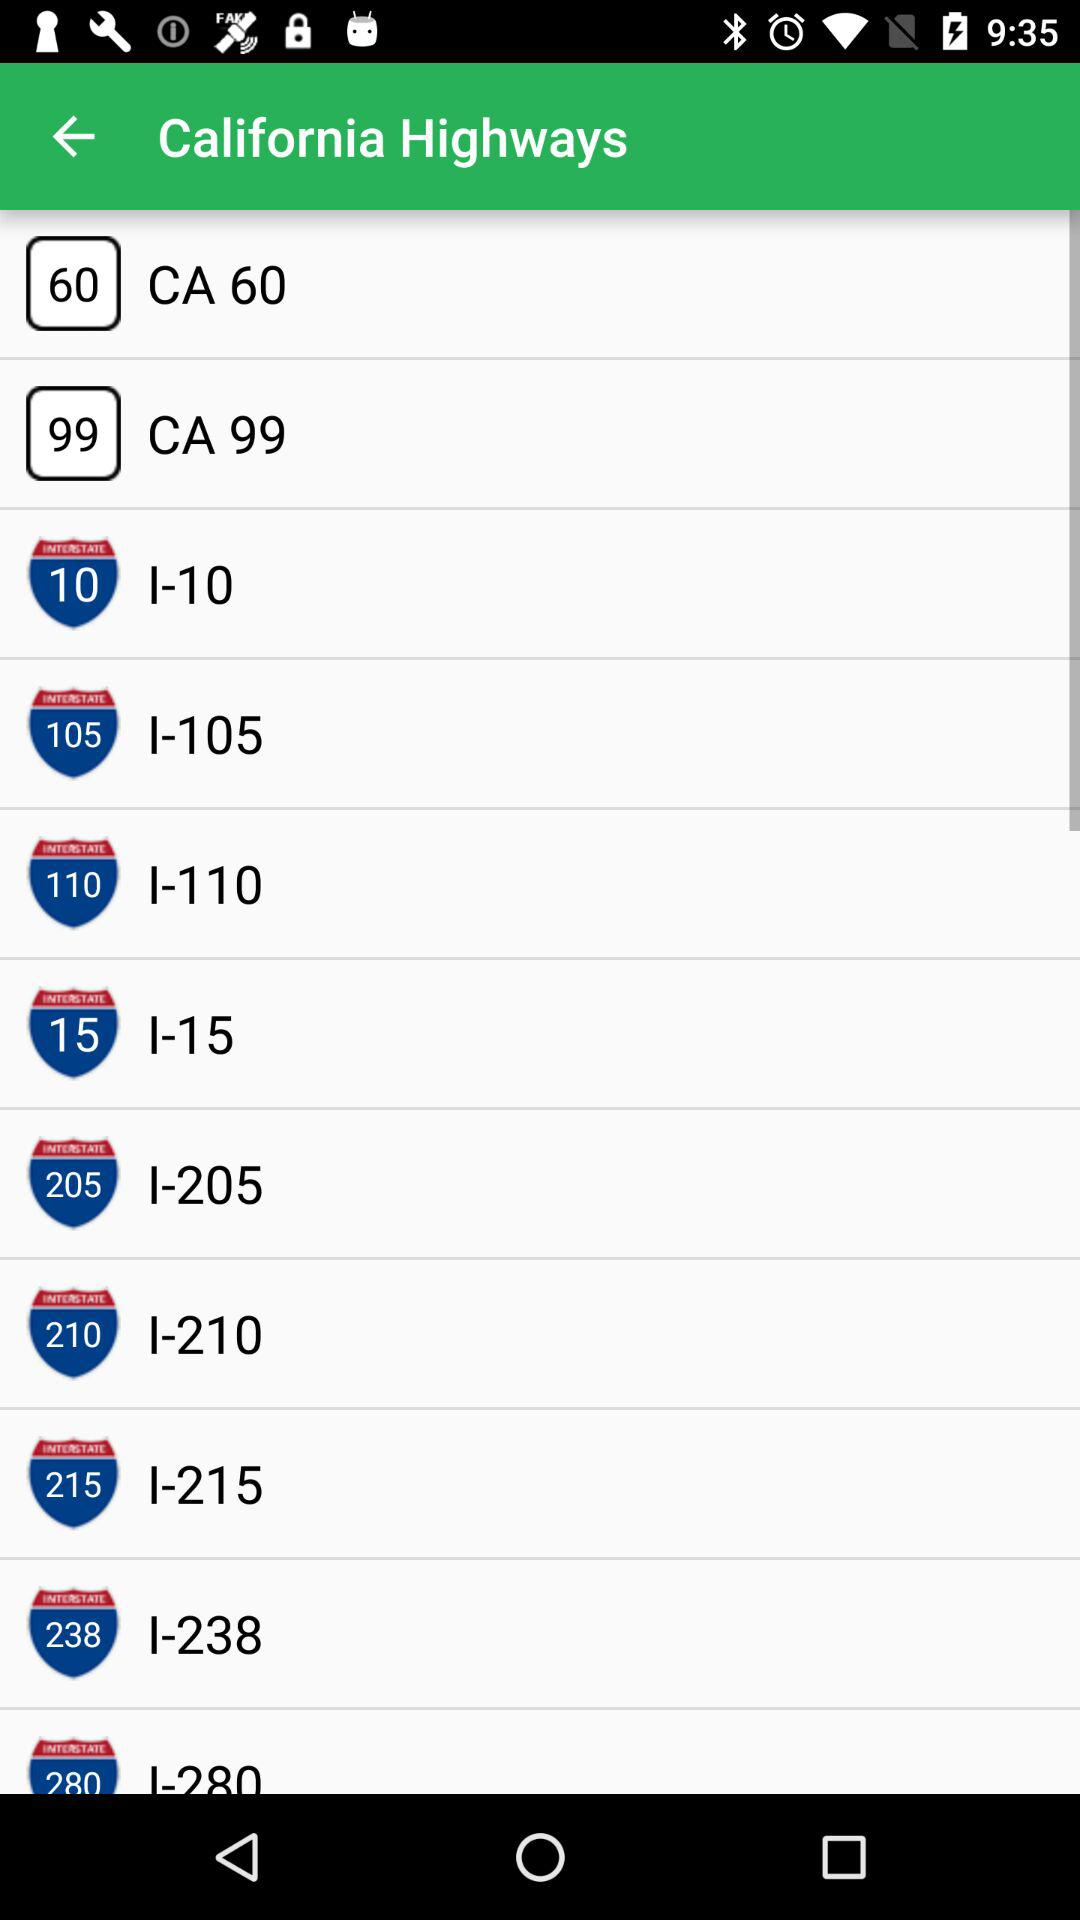Which number shows on the "California Highways I-15"? The shown number is 15. 